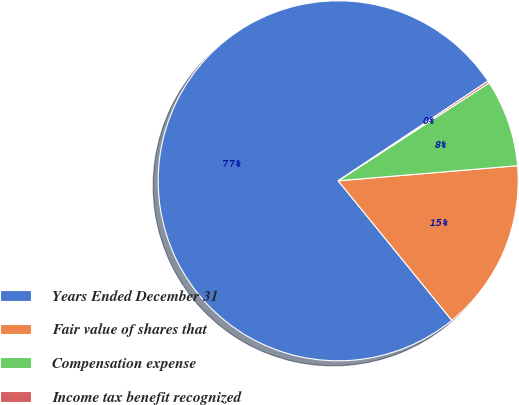Convert chart to OTSL. <chart><loc_0><loc_0><loc_500><loc_500><pie_chart><fcel>Years Ended December 31<fcel>Fair value of shares that<fcel>Compensation expense<fcel>Income tax benefit recognized<nl><fcel>76.53%<fcel>15.46%<fcel>7.82%<fcel>0.19%<nl></chart> 